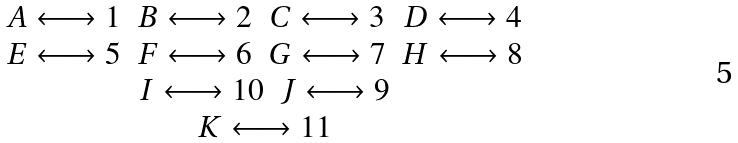Convert formula to latex. <formula><loc_0><loc_0><loc_500><loc_500>\begin{array} { c } \begin{array} { c c c c } A \longleftrightarrow 1 & B \longleftrightarrow 2 & C \longleftrightarrow 3 & D \longleftrightarrow 4 \\ E \longleftrightarrow 5 & F \longleftrightarrow 6 & G \longleftrightarrow 7 & H \longleftrightarrow 8 \\ \end{array} \\ \begin{array} { c c } I \longleftrightarrow 1 0 & J \longleftrightarrow 9 \end{array} \\ K \longleftrightarrow 1 1 \end{array}</formula> 